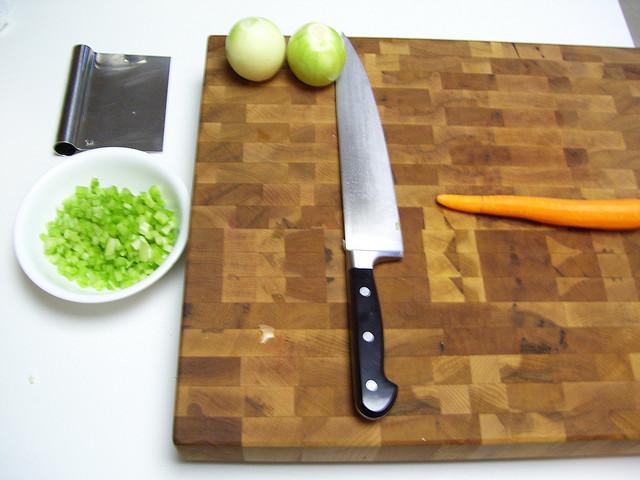How many vegetables can be seen on the cutting board?
Quick response, please. 3. Is the carrot chopped?
Give a very brief answer. No. How many stalks of celery are there?
Concise answer only. 0. What is the cutting board made out of?
Write a very short answer. Wood. 